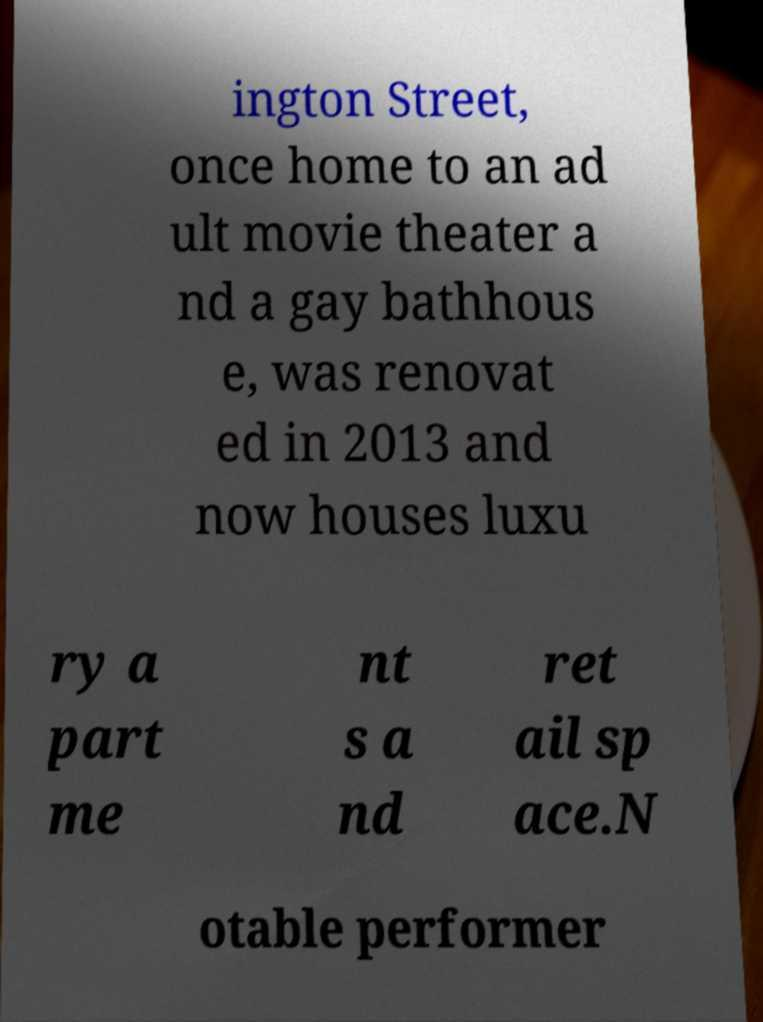I need the written content from this picture converted into text. Can you do that? ington Street, once home to an ad ult movie theater a nd a gay bathhous e, was renovat ed in 2013 and now houses luxu ry a part me nt s a nd ret ail sp ace.N otable performer 